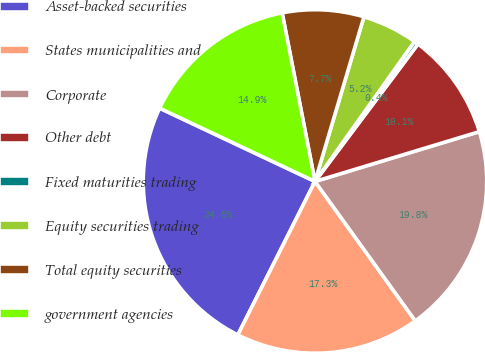Convert chart to OTSL. <chart><loc_0><loc_0><loc_500><loc_500><pie_chart><fcel>Asset-backed securities<fcel>States municipalities and<fcel>Corporate<fcel>Other debt<fcel>Fixed maturities trading<fcel>Equity securities trading<fcel>Total equity securities<fcel>government agencies<nl><fcel>24.6%<fcel>17.34%<fcel>19.76%<fcel>10.08%<fcel>0.4%<fcel>5.24%<fcel>7.66%<fcel>14.92%<nl></chart> 